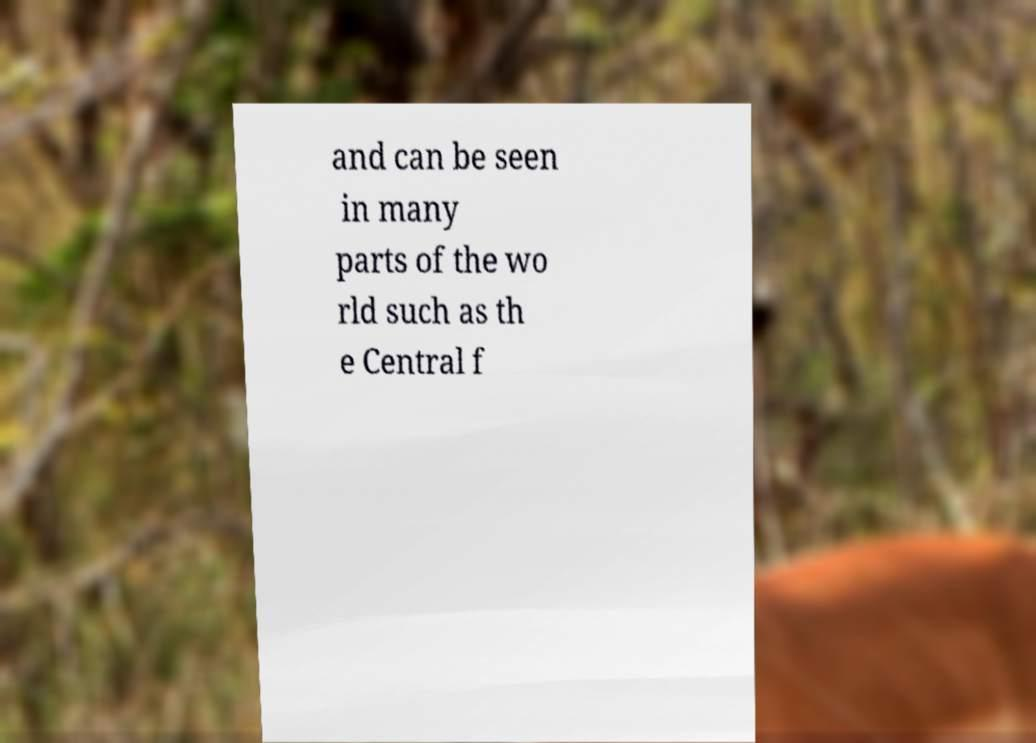Please read and relay the text visible in this image. What does it say? and can be seen in many parts of the wo rld such as th e Central f 